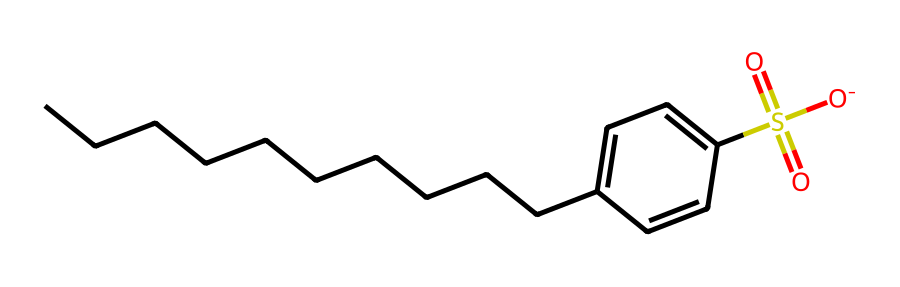What is the main functional group in this detergent? The main functional group is the sulfonate group, indicated by "S(=O)(=O)[O-]" in the SMILES. It denotes the sulfonic acid structural class, which is characteristic of surfactants.
Answer: sulfonate How many carbon atoms are present in the molecule? By counting the "C" characters in the SMILES representation, there are 12 carbon atoms in total in the alkyl chain and the benzene ring.
Answer: 12 What type of chemical compound is represented by this structure? This structure represents an anionic surfactant, characterized by its ability to reduce surface tension and interact with both water and oils.
Answer: anionic surfactant What is the significance of the benzene ring in this detergent? The benzene ring contributes to the hydrophobic (water-repelling) properties of the molecule, which helps in the emulsification process for dirt and oils during washing.
Answer: hydrophobic properties How many oxygen atoms are in the detergent's molecule? The SMILES indicates four oxygen atoms in total ("O" characters appear four times), included in the sulfonate group and one carbonyl group.
Answer: 4 Which part of the molecule is responsible for its surfactant properties? The sulfonate group provides the hydrophilic (water-attracting) part that enables the surfactant to interact effectively with water, enhancing detergent performance.
Answer: sulfonate group Is this compound likely to be biodegradable? Yes, alkyl benzene sulfonates are known for being biodegradable due to their structure, which can be broken down by microorganisms in the environment.
Answer: yes 